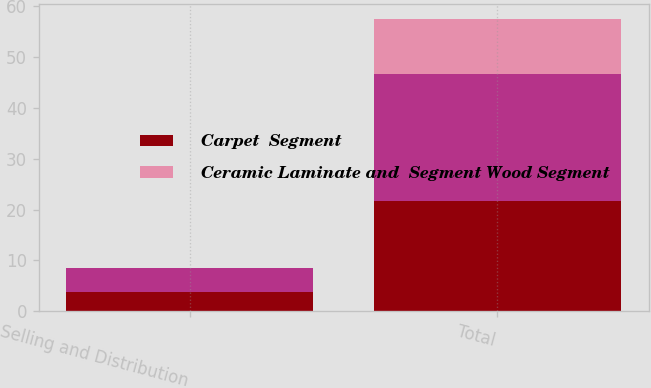Convert chart. <chart><loc_0><loc_0><loc_500><loc_500><stacked_bar_chart><ecel><fcel>Selling and Distribution<fcel>Total<nl><fcel>Carpet  Segment<fcel>3.7<fcel>21.7<nl><fcel>nan<fcel>4.8<fcel>25<nl><fcel>Ceramic Laminate and  Segment Wood Segment<fcel>0.1<fcel>10.9<nl></chart> 